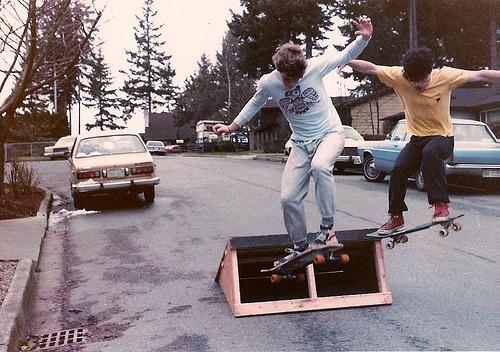How many skateboards are there?
Quick response, please. 2. Are the boys coming out of the box?
Be succinct. No. What are the boys doing?
Give a very brief answer. Skateboarding. How many boys are there?
Concise answer only. 2. 